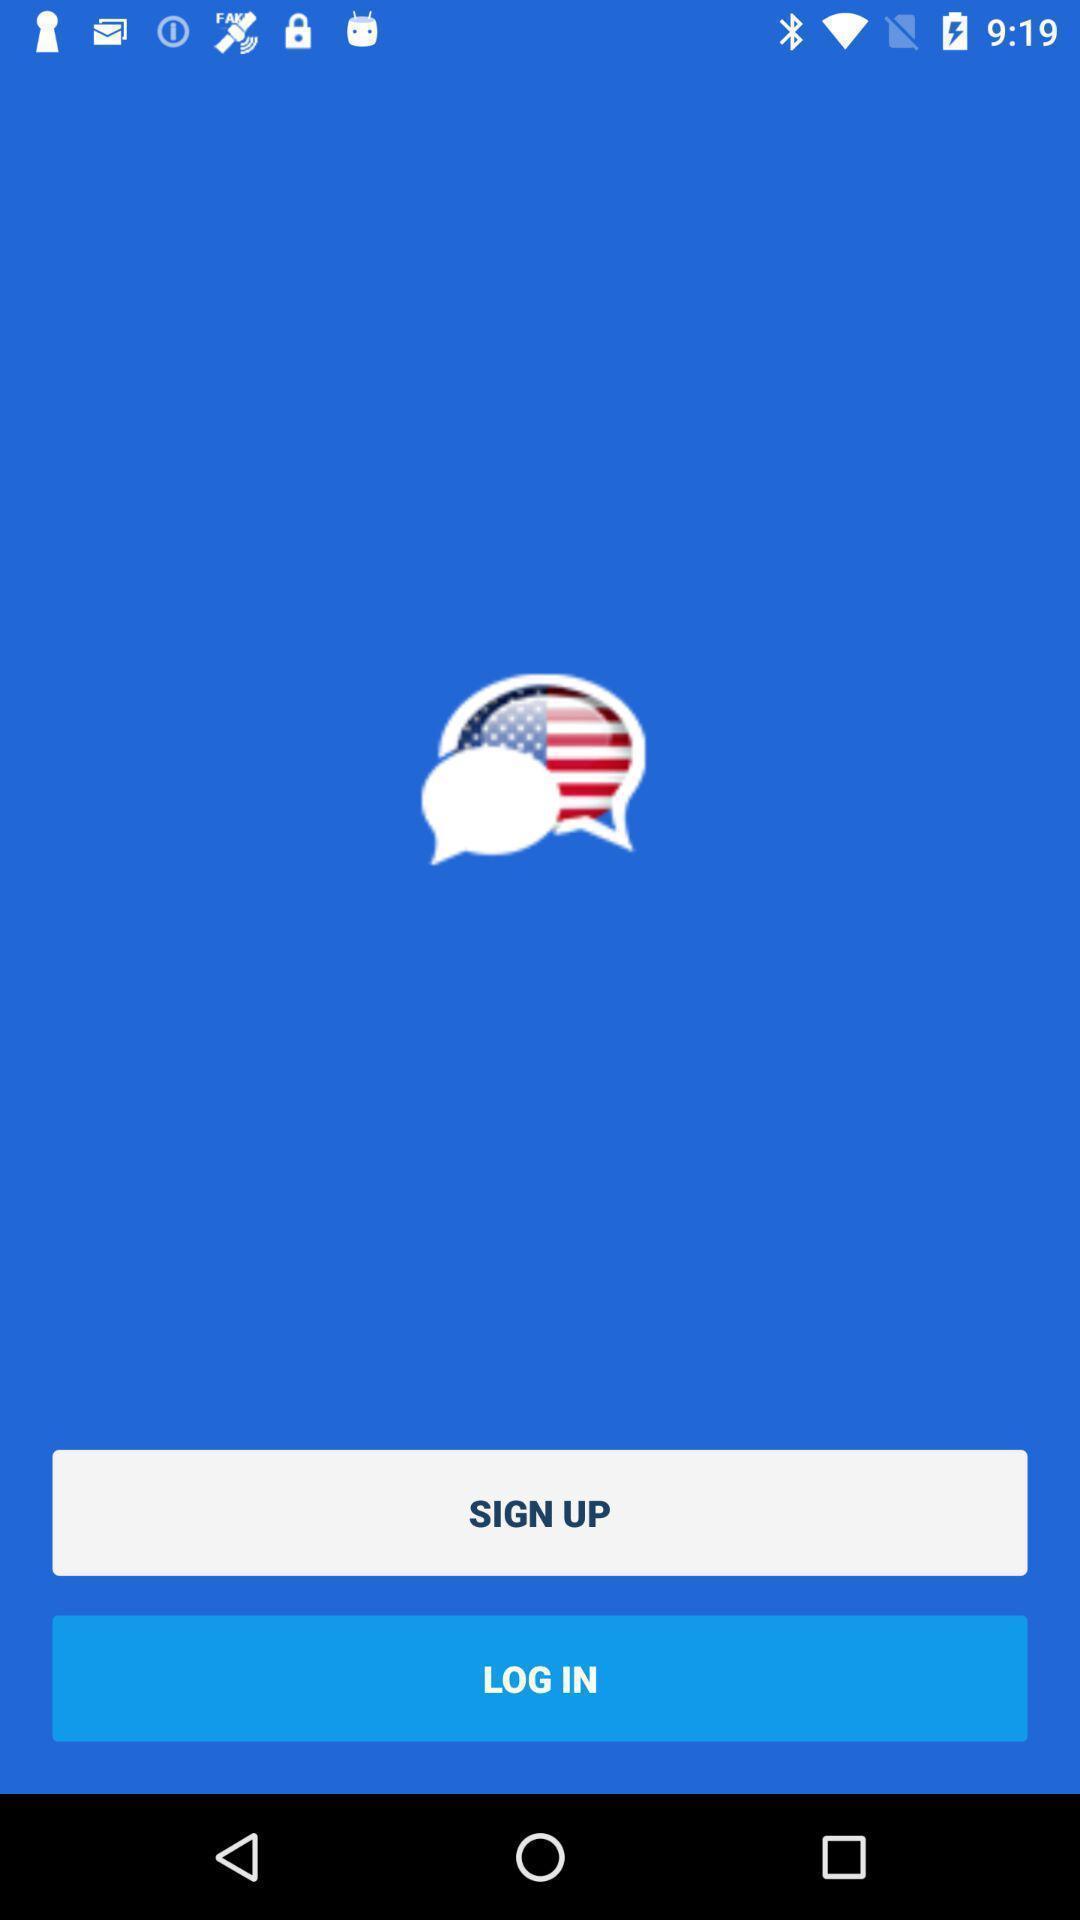Summarize the information in this screenshot. Sign up page. 